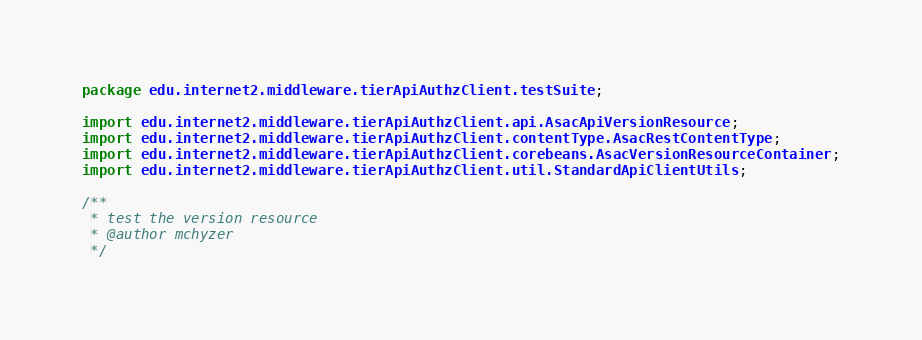Convert code to text. <code><loc_0><loc_0><loc_500><loc_500><_Java_>package edu.internet2.middleware.tierApiAuthzClient.testSuite;

import edu.internet2.middleware.tierApiAuthzClient.api.AsacApiVersionResource;
import edu.internet2.middleware.tierApiAuthzClient.contentType.AsacRestContentType;
import edu.internet2.middleware.tierApiAuthzClient.corebeans.AsacVersionResourceContainer;
import edu.internet2.middleware.tierApiAuthzClient.util.StandardApiClientUtils;

/**
 * test the version resource
 * @author mchyzer
 */</code> 